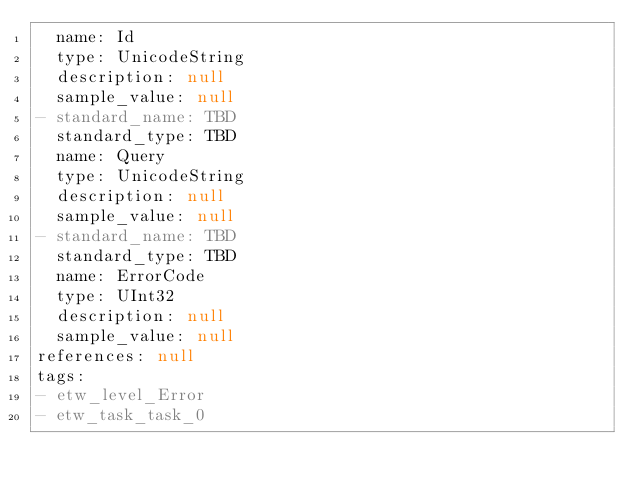<code> <loc_0><loc_0><loc_500><loc_500><_YAML_>  name: Id
  type: UnicodeString
  description: null
  sample_value: null
- standard_name: TBD
  standard_type: TBD
  name: Query
  type: UnicodeString
  description: null
  sample_value: null
- standard_name: TBD
  standard_type: TBD
  name: ErrorCode
  type: UInt32
  description: null
  sample_value: null
references: null
tags:
- etw_level_Error
- etw_task_task_0
</code> 